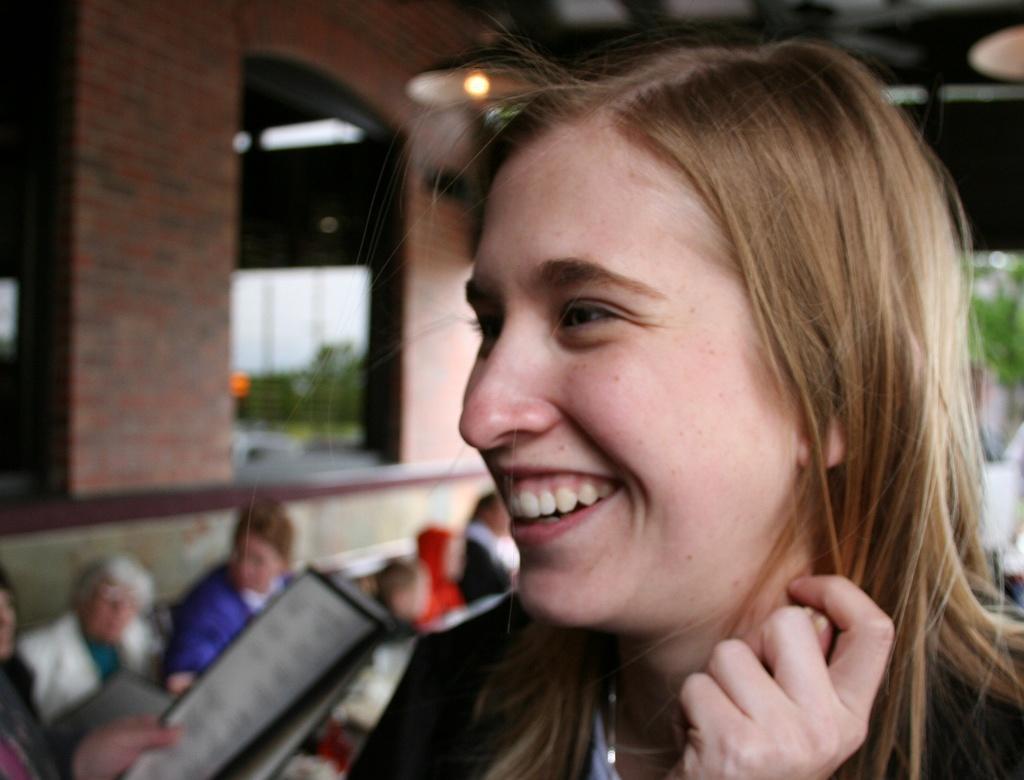How would you summarize this image in a sentence or two? In this picture there is a woman who is wearing black dress and she is smiling. On the left there is another person who is holding the papers. Beside him I can see some peoples were sitting on the chair. On the left I can see the windows on the wall. At the top I can see the lights which are hanging from the roof. In the background I can see the trees, buildings, poles and other objects. 